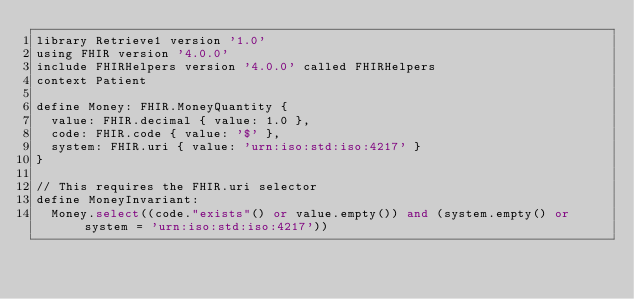<code> <loc_0><loc_0><loc_500><loc_500><_SQL_>library Retrieve1 version '1.0'
using FHIR version '4.0.0'
include FHIRHelpers version '4.0.0' called FHIRHelpers
context Patient

define Money: FHIR.MoneyQuantity {
  value: FHIR.decimal { value: 1.0 },
  code: FHIR.code { value: '$' },
  system: FHIR.uri { value: 'urn:iso:std:iso:4217' }
}

// This requires the FHIR.uri selector
define MoneyInvariant:
  Money.select((code."exists"() or value.empty()) and (system.empty() or system = 'urn:iso:std:iso:4217'))
</code> 